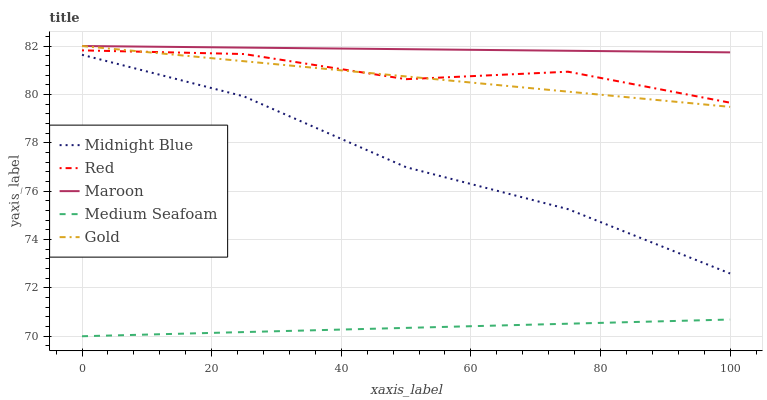Does Medium Seafoam have the minimum area under the curve?
Answer yes or no. Yes. Does Maroon have the maximum area under the curve?
Answer yes or no. Yes. Does Gold have the minimum area under the curve?
Answer yes or no. No. Does Gold have the maximum area under the curve?
Answer yes or no. No. Is Maroon the smoothest?
Answer yes or no. Yes. Is Red the roughest?
Answer yes or no. Yes. Is Midnight Blue the smoothest?
Answer yes or no. No. Is Midnight Blue the roughest?
Answer yes or no. No. Does Gold have the lowest value?
Answer yes or no. No. Does Midnight Blue have the highest value?
Answer yes or no. No. Is Midnight Blue less than Red?
Answer yes or no. Yes. Is Midnight Blue greater than Medium Seafoam?
Answer yes or no. Yes. Does Midnight Blue intersect Red?
Answer yes or no. No. 